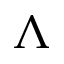Convert formula to latex. <formula><loc_0><loc_0><loc_500><loc_500>\Lambda</formula> 